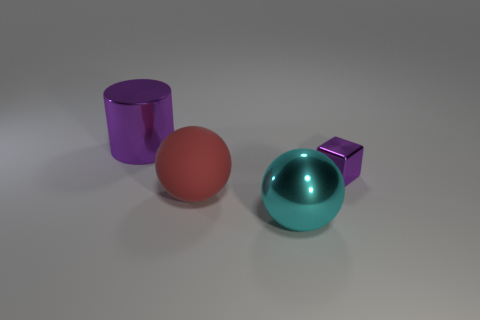Is there anything else that is made of the same material as the large red object?
Provide a short and direct response. No. There is a metal thing that is on the left side of the big red matte thing; is there a tiny purple object in front of it?
Your answer should be compact. Yes. Is there a large metal ball?
Offer a terse response. Yes. The large shiny thing right of the purple thing left of the cyan thing is what color?
Offer a terse response. Cyan. What material is the big cyan thing that is the same shape as the big red object?
Ensure brevity in your answer.  Metal. What number of other balls have the same size as the rubber ball?
Keep it short and to the point. 1. The cube that is the same material as the cylinder is what size?
Your response must be concise. Small. What number of other cyan things are the same shape as the large rubber thing?
Your answer should be very brief. 1. What number of small green matte objects are there?
Provide a succinct answer. 0. There is a large metallic object that is behind the large rubber thing; does it have the same shape as the cyan thing?
Keep it short and to the point. No. 